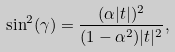Convert formula to latex. <formula><loc_0><loc_0><loc_500><loc_500>\sin ^ { 2 } ( \gamma ) = \frac { ( \alpha | t | ) ^ { 2 } } { ( 1 - \alpha ^ { 2 } ) | t | ^ { 2 } } ,</formula> 